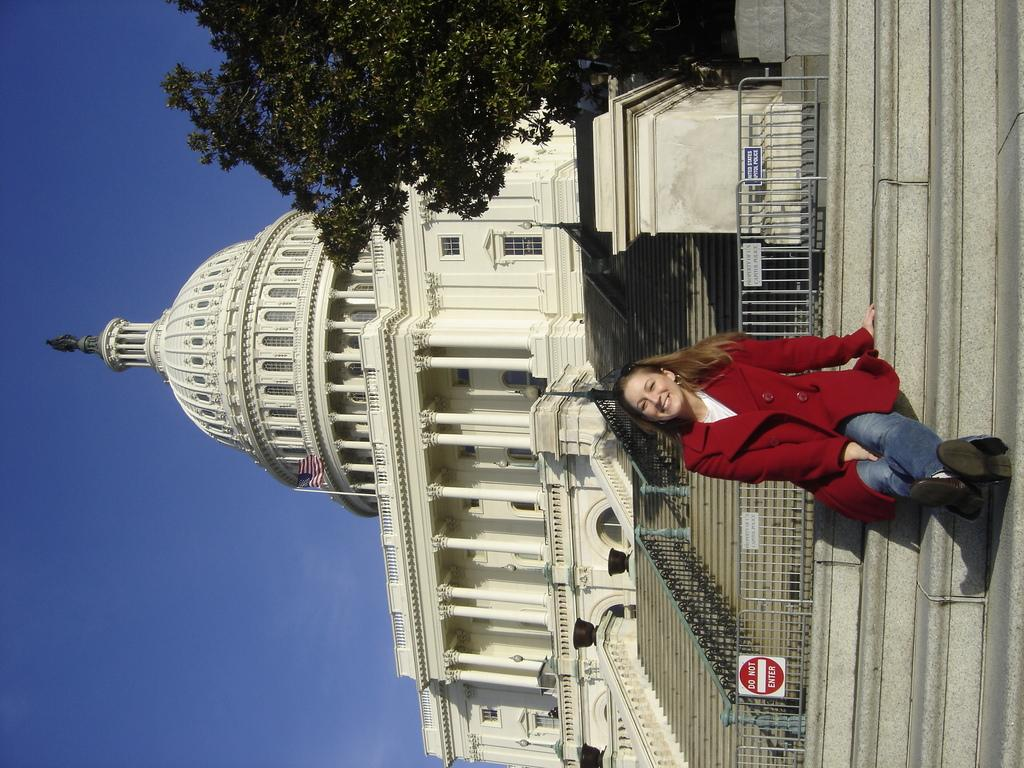What type of structure is present in the image? There are stairs and buildings in the image. What architectural feature can be seen on the buildings? There are windows visible on the buildings. What is the woman in the image wearing? The woman is wearing a red dress in the image. What type of vegetation is present in the image? There is visible on the left side of the image. What mark does the woman make on the tree in the image? There is no mark made by the woman on the tree in the image, as there is no indication of any interaction between the woman and the tree. 